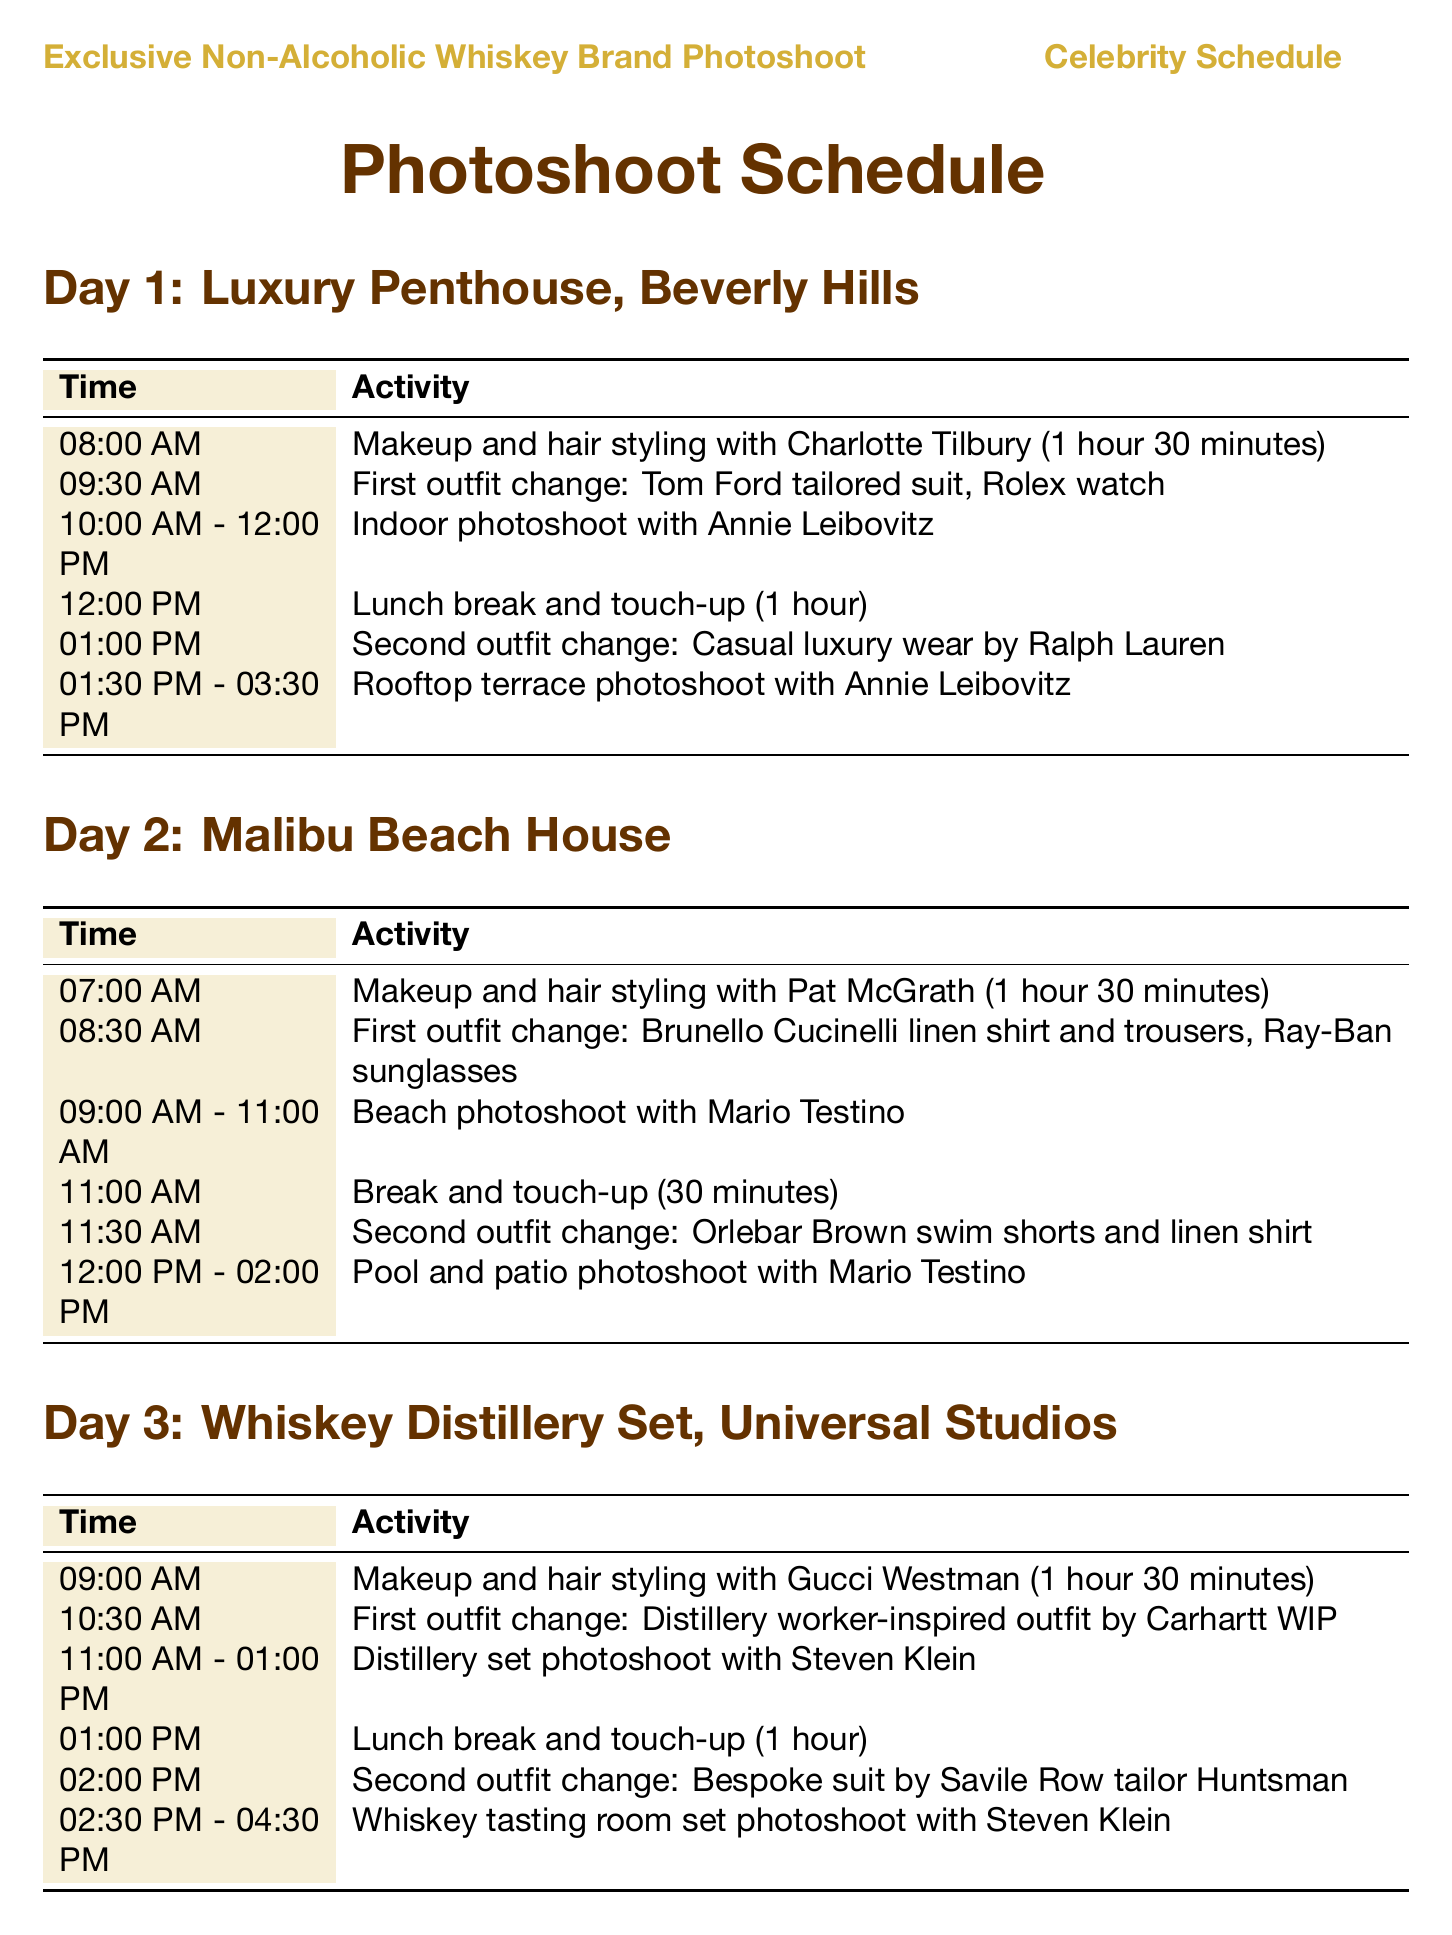What is the location for Day 1? The first day's location is specified in the schedule as "Luxury Penthouse, Beverly Hills."
Answer: Luxury Penthouse, Beverly Hills Who is the stylist for Day 2's makeup session? The makeup session for Day 2 features Pat McGrath as the stylist according to the schedule.
Answer: Pat McGrath What time does the indoor photoshoot start on Day 1? The indoor photoshoot on Day 1 begins at 10:00 AM, as shown in the timetable.
Answer: 10:00 AM How long is the makeup and hair styling session on Day 3? The document states that the makeup and hair styling session on Day 3 lasts for 1 hour 30 minutes.
Answer: 1 hour 30 minutes What outfit is changed into after lunch on Day 2? The second outfit change after lunch on Day 2 is "Orlebar Brown swim shorts and linen shirt" according to the details provided.
Answer: Orlebar Brown swim shorts and linen shirt Which photographer is scheduled for the rooftop terrace photoshoot? The photographer for the rooftop terrace photoshoot is Annie Leibovitz, as indicated in the schedule.
Answer: Annie Leibovitz What is the total duration of all photoshoot sessions on Day 3? The photoshoot sessions on Day 3 have two main durations: 2 hours for the distillery set and 2 hours for the whiskey tasting room, totaling 4 hours of photoshoot time.
Answer: 4 hours What is the accessory used with the first outfit change on Day 1? The accessory paired with the first outfit change on Day 1 is a Rolex watch, as mentioned in the schedule.
Answer: Rolex watch 